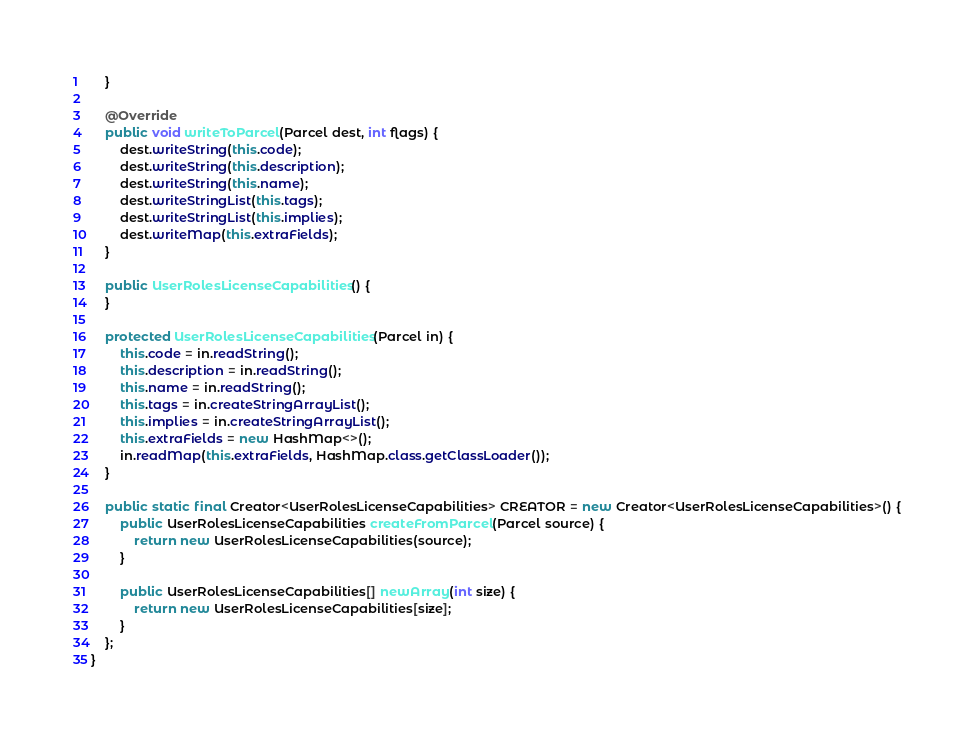<code> <loc_0><loc_0><loc_500><loc_500><_Java_>    }

    @Override
    public void writeToParcel(Parcel dest, int flags) {
        dest.writeString(this.code);
        dest.writeString(this.description);
        dest.writeString(this.name);
        dest.writeStringList(this.tags);
        dest.writeStringList(this.implies);
        dest.writeMap(this.extraFields);
    }

    public UserRolesLicenseCapabilities() {
    }

    protected UserRolesLicenseCapabilities(Parcel in) {
        this.code = in.readString();
        this.description = in.readString();
        this.name = in.readString();
        this.tags = in.createStringArrayList();
        this.implies = in.createStringArrayList();
        this.extraFields = new HashMap<>();
        in.readMap(this.extraFields, HashMap.class.getClassLoader());
    }

    public static final Creator<UserRolesLicenseCapabilities> CREATOR = new Creator<UserRolesLicenseCapabilities>() {
        public UserRolesLicenseCapabilities createFromParcel(Parcel source) {
            return new UserRolesLicenseCapabilities(source);
        }

        public UserRolesLicenseCapabilities[] newArray(int size) {
            return new UserRolesLicenseCapabilities[size];
        }
    };
}
</code> 